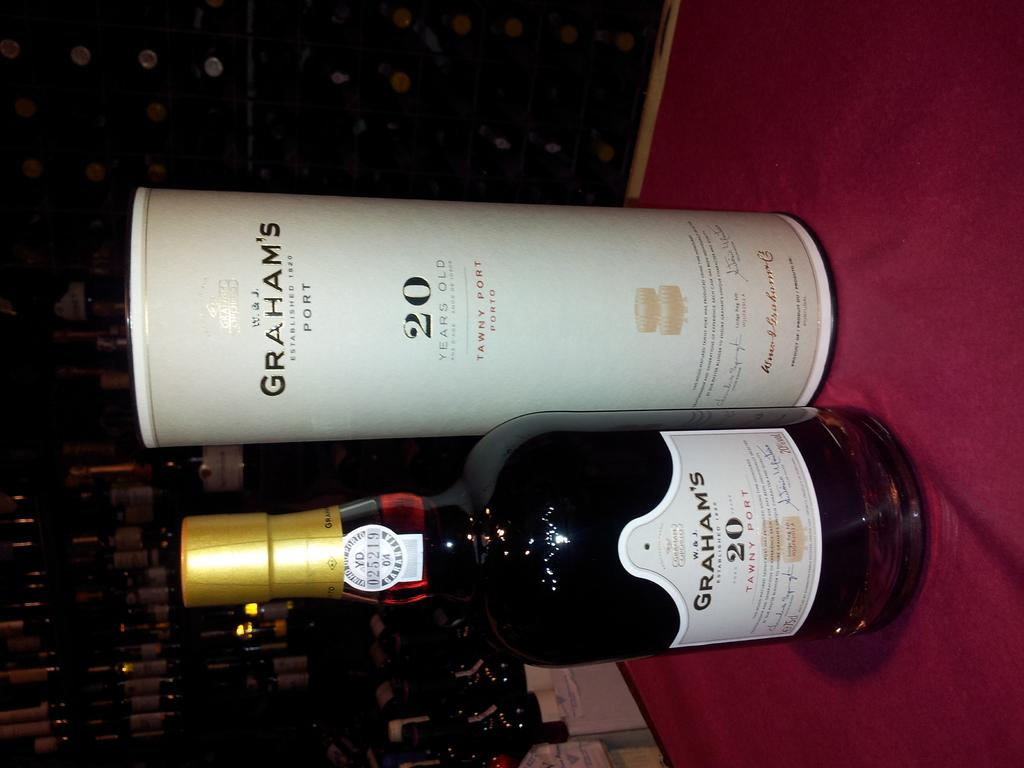What is the main object in the middle of the image? There is a wine bottle in the middle of the image. Where is the wine bottle located? The wine bottle is on a table. Are there any other wine bottles visible in the image? Yes, there are additional wine bottles on the left side of the image. What type of pancake is being exchanged between the wine bottles in the image? There is no pancake present in the image, and the wine bottles are not exchanging anything. 